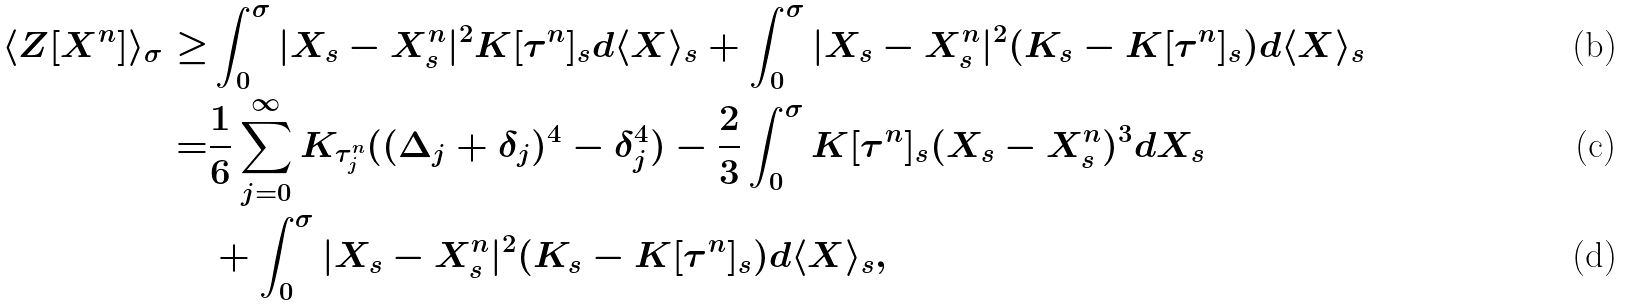<formula> <loc_0><loc_0><loc_500><loc_500>\langle Z [ X ^ { n } ] \rangle _ { \sigma } \geq & \int _ { 0 } ^ { \sigma } | X _ { s } - X ^ { n } _ { s } | ^ { 2 } K [ \tau ^ { n } ] _ { s } d \langle X \rangle _ { s } + \int _ { 0 } ^ { \sigma } | X _ { s } - X ^ { n } _ { s } | ^ { 2 } ( K _ { s } - K [ \tau ^ { n } ] _ { s } ) d \langle X \rangle _ { s } \\ = & \frac { 1 } { 6 } \sum _ { j = 0 } ^ { \infty } K _ { \tau ^ { n } _ { j } } ( ( \Delta _ { j } + \delta _ { j } ) ^ { 4 } - \delta _ { j } ^ { 4 } ) - \frac { 2 } { 3 } \int _ { 0 } ^ { \sigma } K [ \tau ^ { n } ] _ { s } ( X _ { s } - X ^ { n } _ { s } ) ^ { 3 } d X _ { s } \\ & + \int _ { 0 } ^ { \sigma } | X _ { s } - X ^ { n } _ { s } | ^ { 2 } ( K _ { s } - K [ \tau ^ { n } ] _ { s } ) d \langle X \rangle _ { s } ,</formula> 